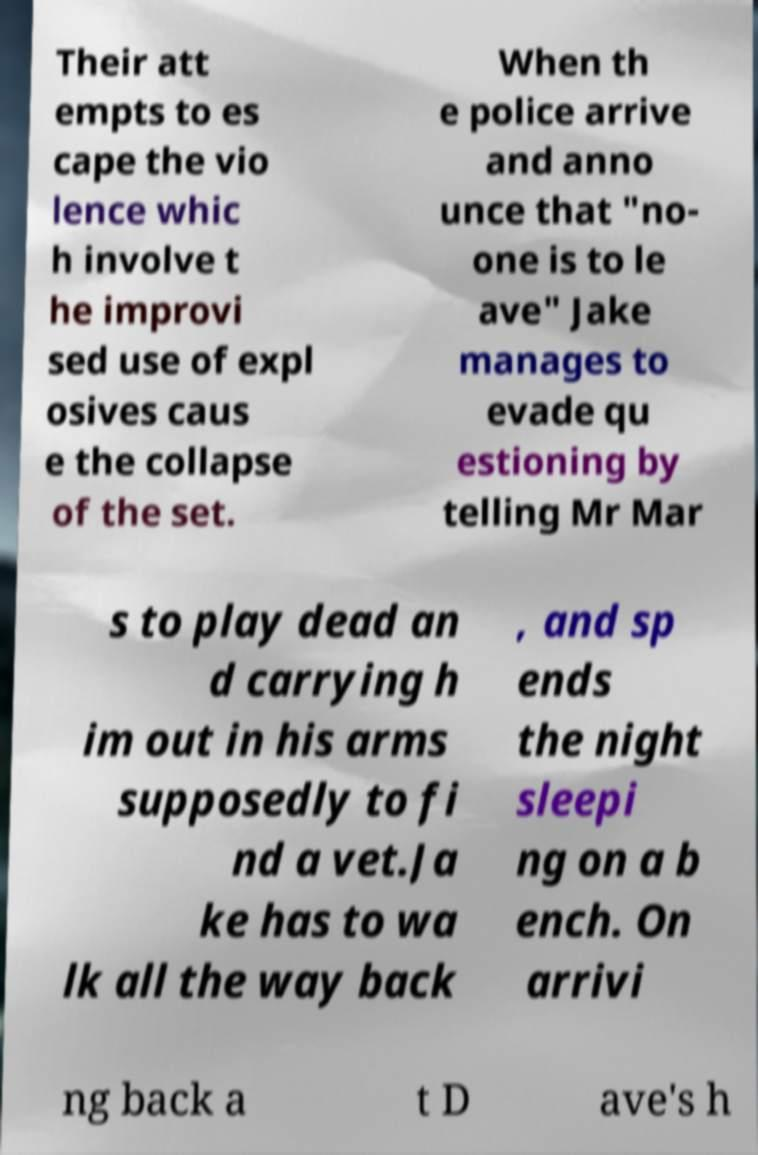Please read and relay the text visible in this image. What does it say? Their att empts to es cape the vio lence whic h involve t he improvi sed use of expl osives caus e the collapse of the set. When th e police arrive and anno unce that "no- one is to le ave" Jake manages to evade qu estioning by telling Mr Mar s to play dead an d carrying h im out in his arms supposedly to fi nd a vet.Ja ke has to wa lk all the way back , and sp ends the night sleepi ng on a b ench. On arrivi ng back a t D ave's h 